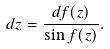Convert formula to latex. <formula><loc_0><loc_0><loc_500><loc_500>d z = \frac { d f ( z ) } { \sin f ( z ) } .</formula> 